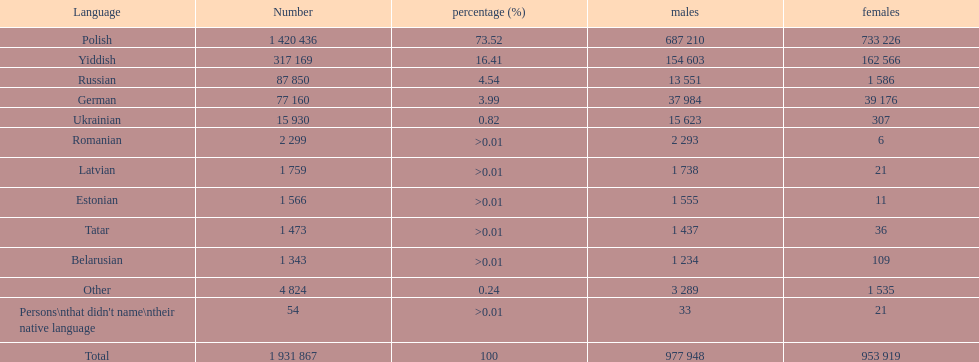What specified native tongues spoken in the warsaw governorate have more males than females? Russian, Ukrainian, Romanian, Latvian, Estonian, Tatar, Belarusian. Which of those have less than 500 males listed? Romanian, Latvian, Estonian, Tatar, Belarusian. Of the remaining languages, which of them have less than 20 females? Romanian, Estonian. Which of these has the largest total number listed? Romanian. 